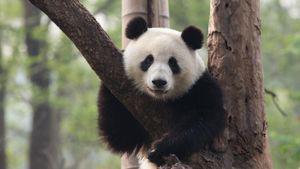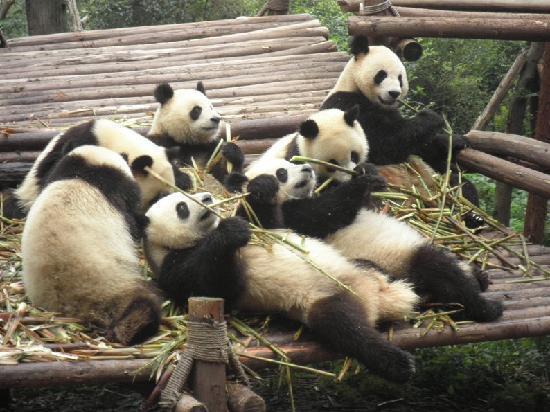The first image is the image on the left, the second image is the image on the right. For the images shown, is this caption "At least one panda is sitting in an open grassy area in one of the images." true? Answer yes or no. No. The first image is the image on the left, the second image is the image on the right. For the images displayed, is the sentence "An image shows multiple pandas with green stalks for munching, on a structure of joined logs." factually correct? Answer yes or no. Yes. 